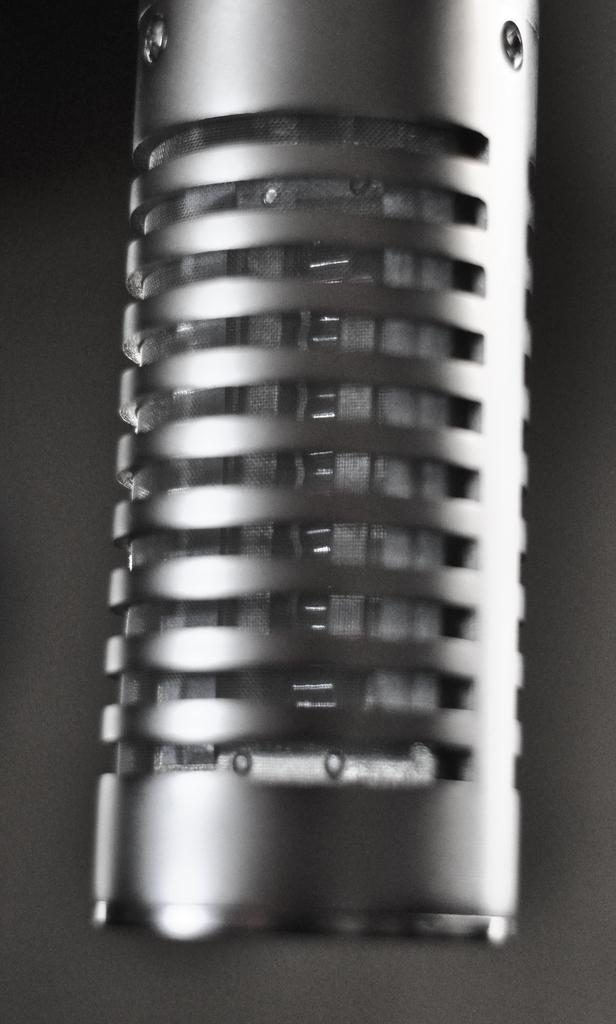What object is the main subject in the image? There is a microphone in the image. How many toes can be seen on the person holding the microphone in the image? There is no person visible in the image, and therefore no toes can be seen. 